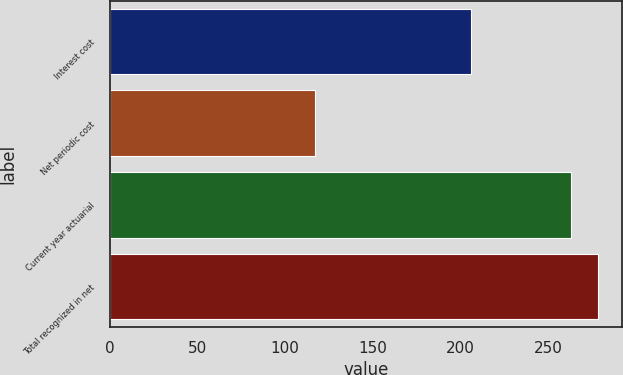Convert chart. <chart><loc_0><loc_0><loc_500><loc_500><bar_chart><fcel>Interest cost<fcel>Net periodic cost<fcel>Current year actuarial<fcel>Total recognized in net<nl><fcel>206<fcel>117<fcel>263<fcel>278.3<nl></chart> 